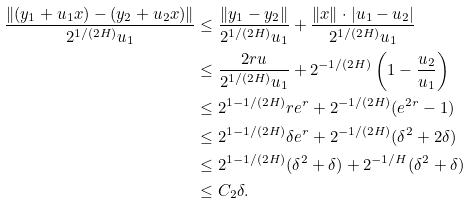Convert formula to latex. <formula><loc_0><loc_0><loc_500><loc_500>\frac { \| ( y _ { 1 } + u _ { 1 } x ) - ( y _ { 2 } + u _ { 2 } x ) \| } { 2 ^ { 1 / ( 2 H ) } u _ { 1 } } & \leq \frac { \| y _ { 1 } - y _ { 2 } \| } { 2 ^ { 1 / ( 2 H ) } u _ { 1 } } + \frac { \| x \| \cdot | u _ { 1 } - u _ { 2 } | } { 2 ^ { 1 / ( 2 H ) } u _ { 1 } } \\ & \leq \frac { 2 r u } { 2 ^ { 1 / ( 2 H ) } u _ { 1 } } + 2 ^ { - 1 / ( 2 H ) } \left ( 1 - \frac { u _ { 2 } } { u _ { 1 } } \right ) \\ & \leq 2 ^ { 1 - 1 / ( 2 H ) } r e ^ { r } + 2 ^ { - 1 / ( 2 H ) } ( e ^ { 2 r } - 1 ) \\ & \leq 2 ^ { 1 - 1 / ( 2 H ) } \delta e ^ { r } + 2 ^ { - 1 / ( 2 H ) } ( \delta ^ { 2 } + 2 \delta ) \\ & \leq 2 ^ { 1 - 1 / ( 2 H ) } ( \delta ^ { 2 } + \delta ) + 2 ^ { - 1 / H } ( \delta ^ { 2 } + \delta ) \\ & \leq C _ { 2 } \delta .</formula> 